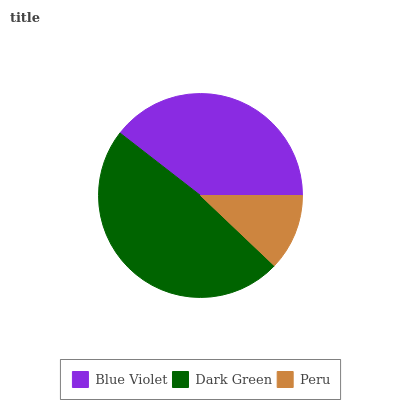Is Peru the minimum?
Answer yes or no. Yes. Is Dark Green the maximum?
Answer yes or no. Yes. Is Dark Green the minimum?
Answer yes or no. No. Is Peru the maximum?
Answer yes or no. No. Is Dark Green greater than Peru?
Answer yes or no. Yes. Is Peru less than Dark Green?
Answer yes or no. Yes. Is Peru greater than Dark Green?
Answer yes or no. No. Is Dark Green less than Peru?
Answer yes or no. No. Is Blue Violet the high median?
Answer yes or no. Yes. Is Blue Violet the low median?
Answer yes or no. Yes. Is Peru the high median?
Answer yes or no. No. Is Peru the low median?
Answer yes or no. No. 